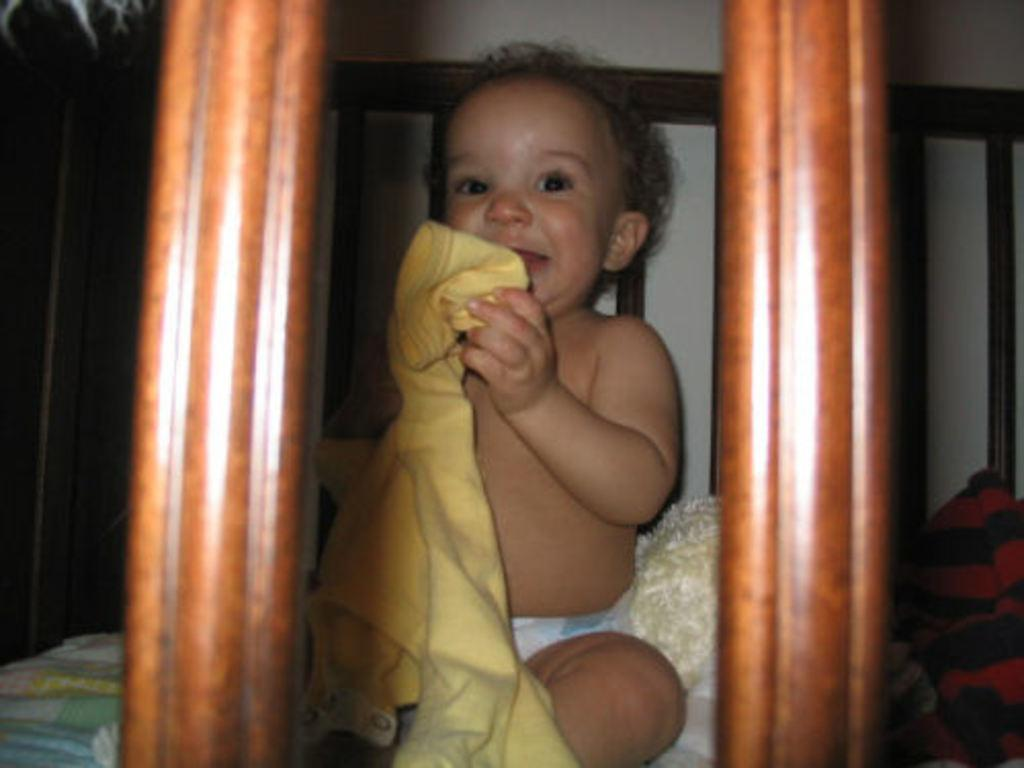What is the main subject of the image? The main subject of the image is a kid. Where is the kid located in the image? The kid is sitting on the bed. What is the kid holding in the image? The kid is holding a cloth. What else can be seen near the kid in the image? There are objects beside the kid. What type of popcorn is the kid eating in the image? There is no popcorn present in the image, and therefore no popcorn can be seen in the kid's hands or mouth. 